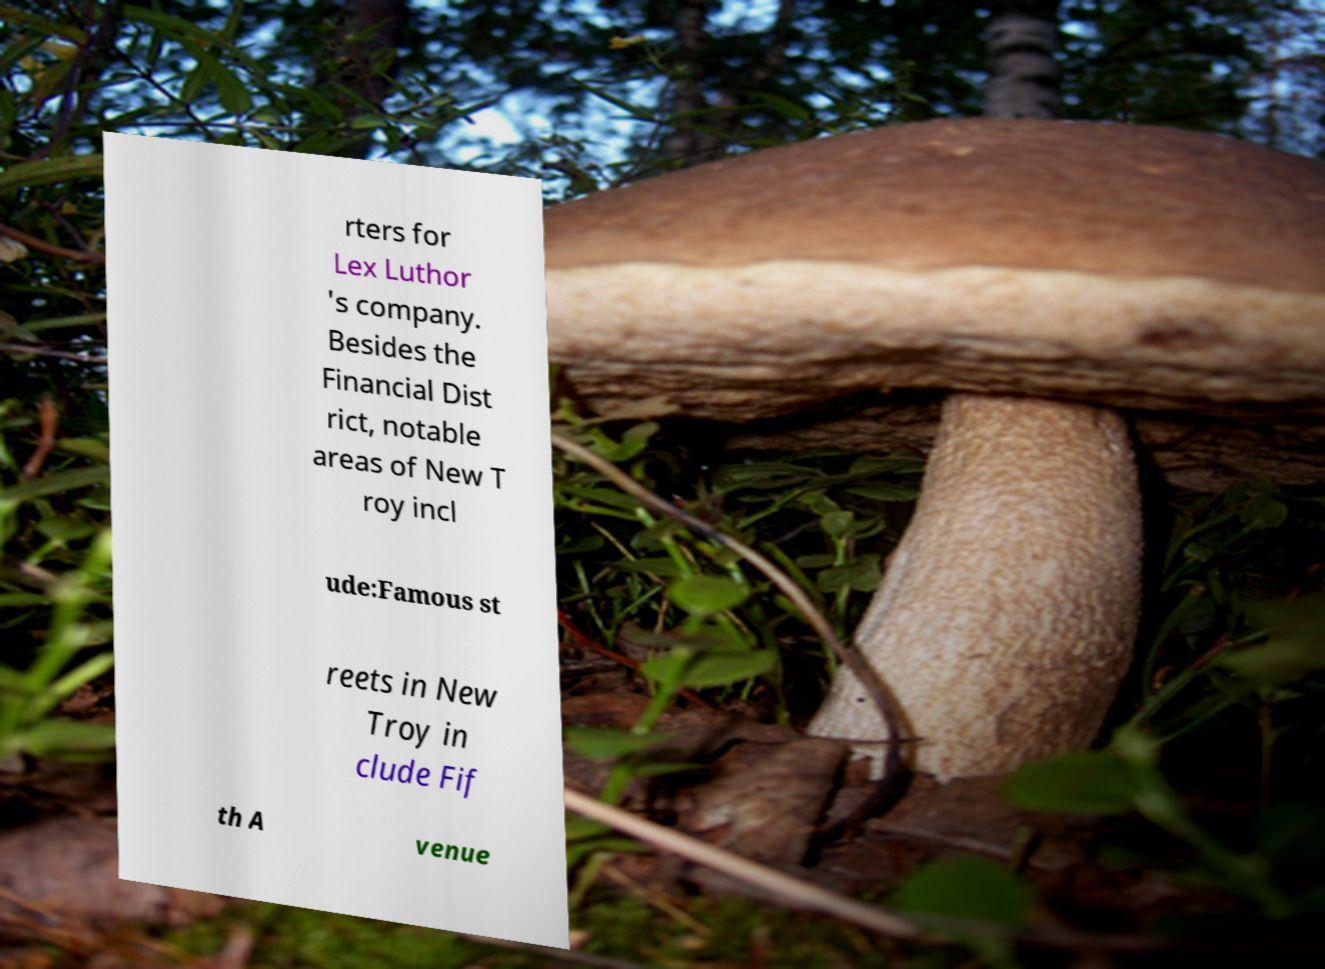For documentation purposes, I need the text within this image transcribed. Could you provide that? rters for Lex Luthor 's company. Besides the Financial Dist rict, notable areas of New T roy incl ude:Famous st reets in New Troy in clude Fif th A venue 